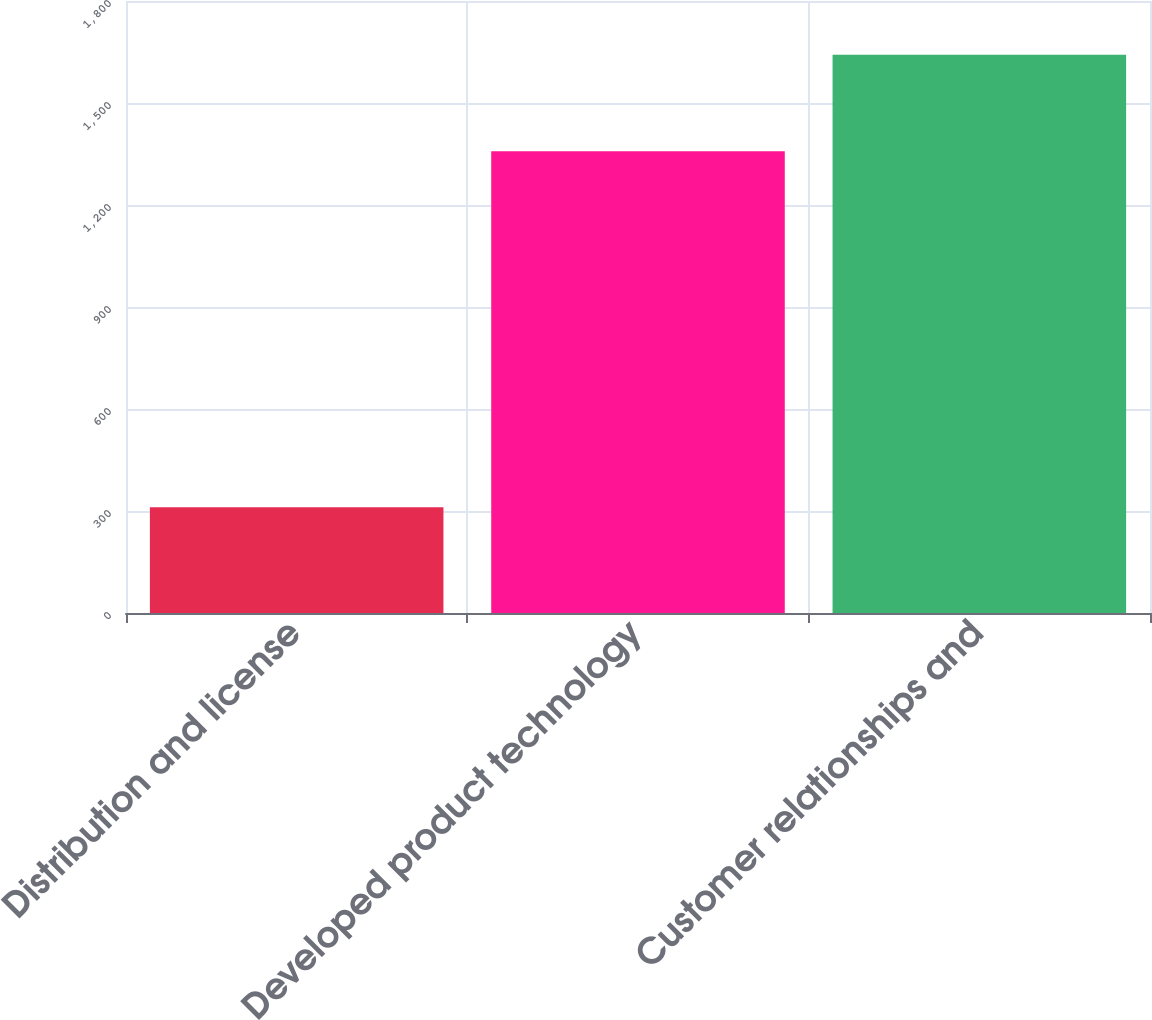<chart> <loc_0><loc_0><loc_500><loc_500><bar_chart><fcel>Distribution and license<fcel>Developed product technology<fcel>Customer relationships and<nl><fcel>311.2<fcel>1358.4<fcel>1642<nl></chart> 